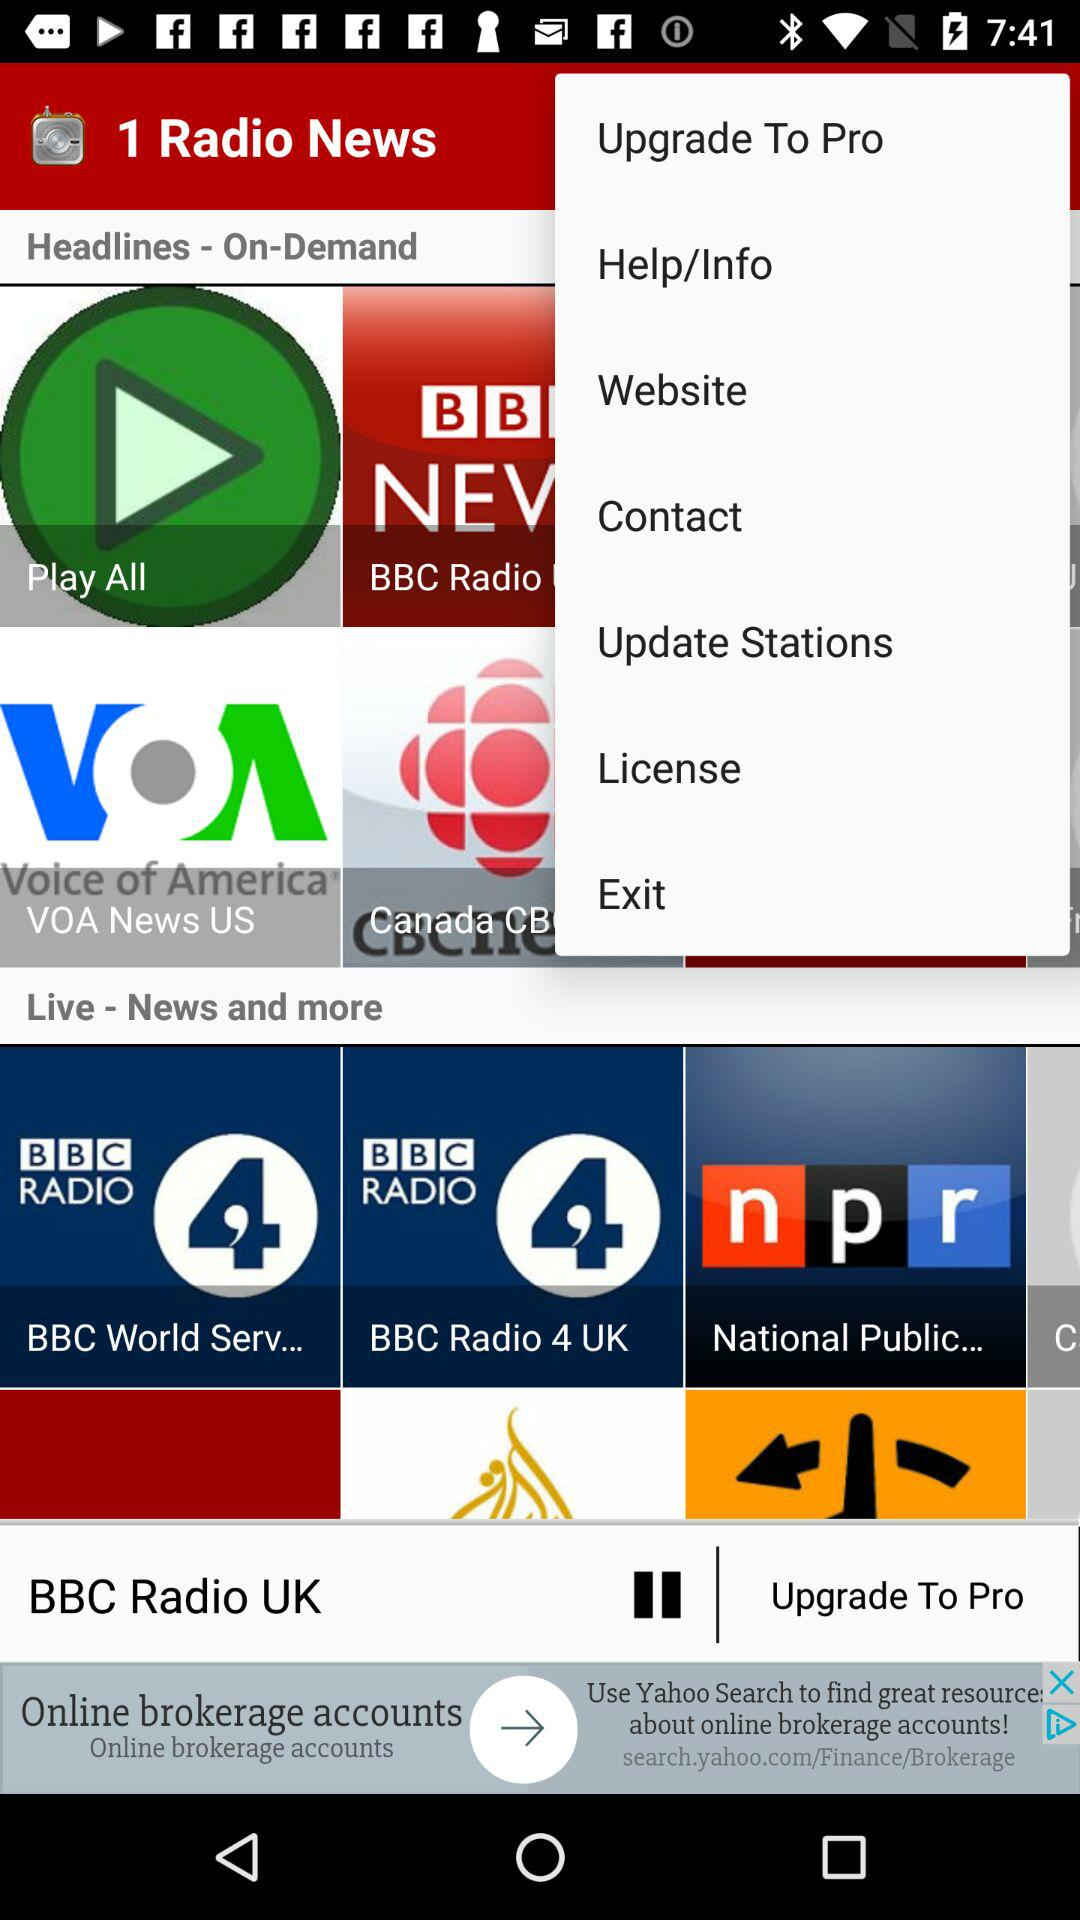What is the name of the application? The name of the application is "1 Radio News". 